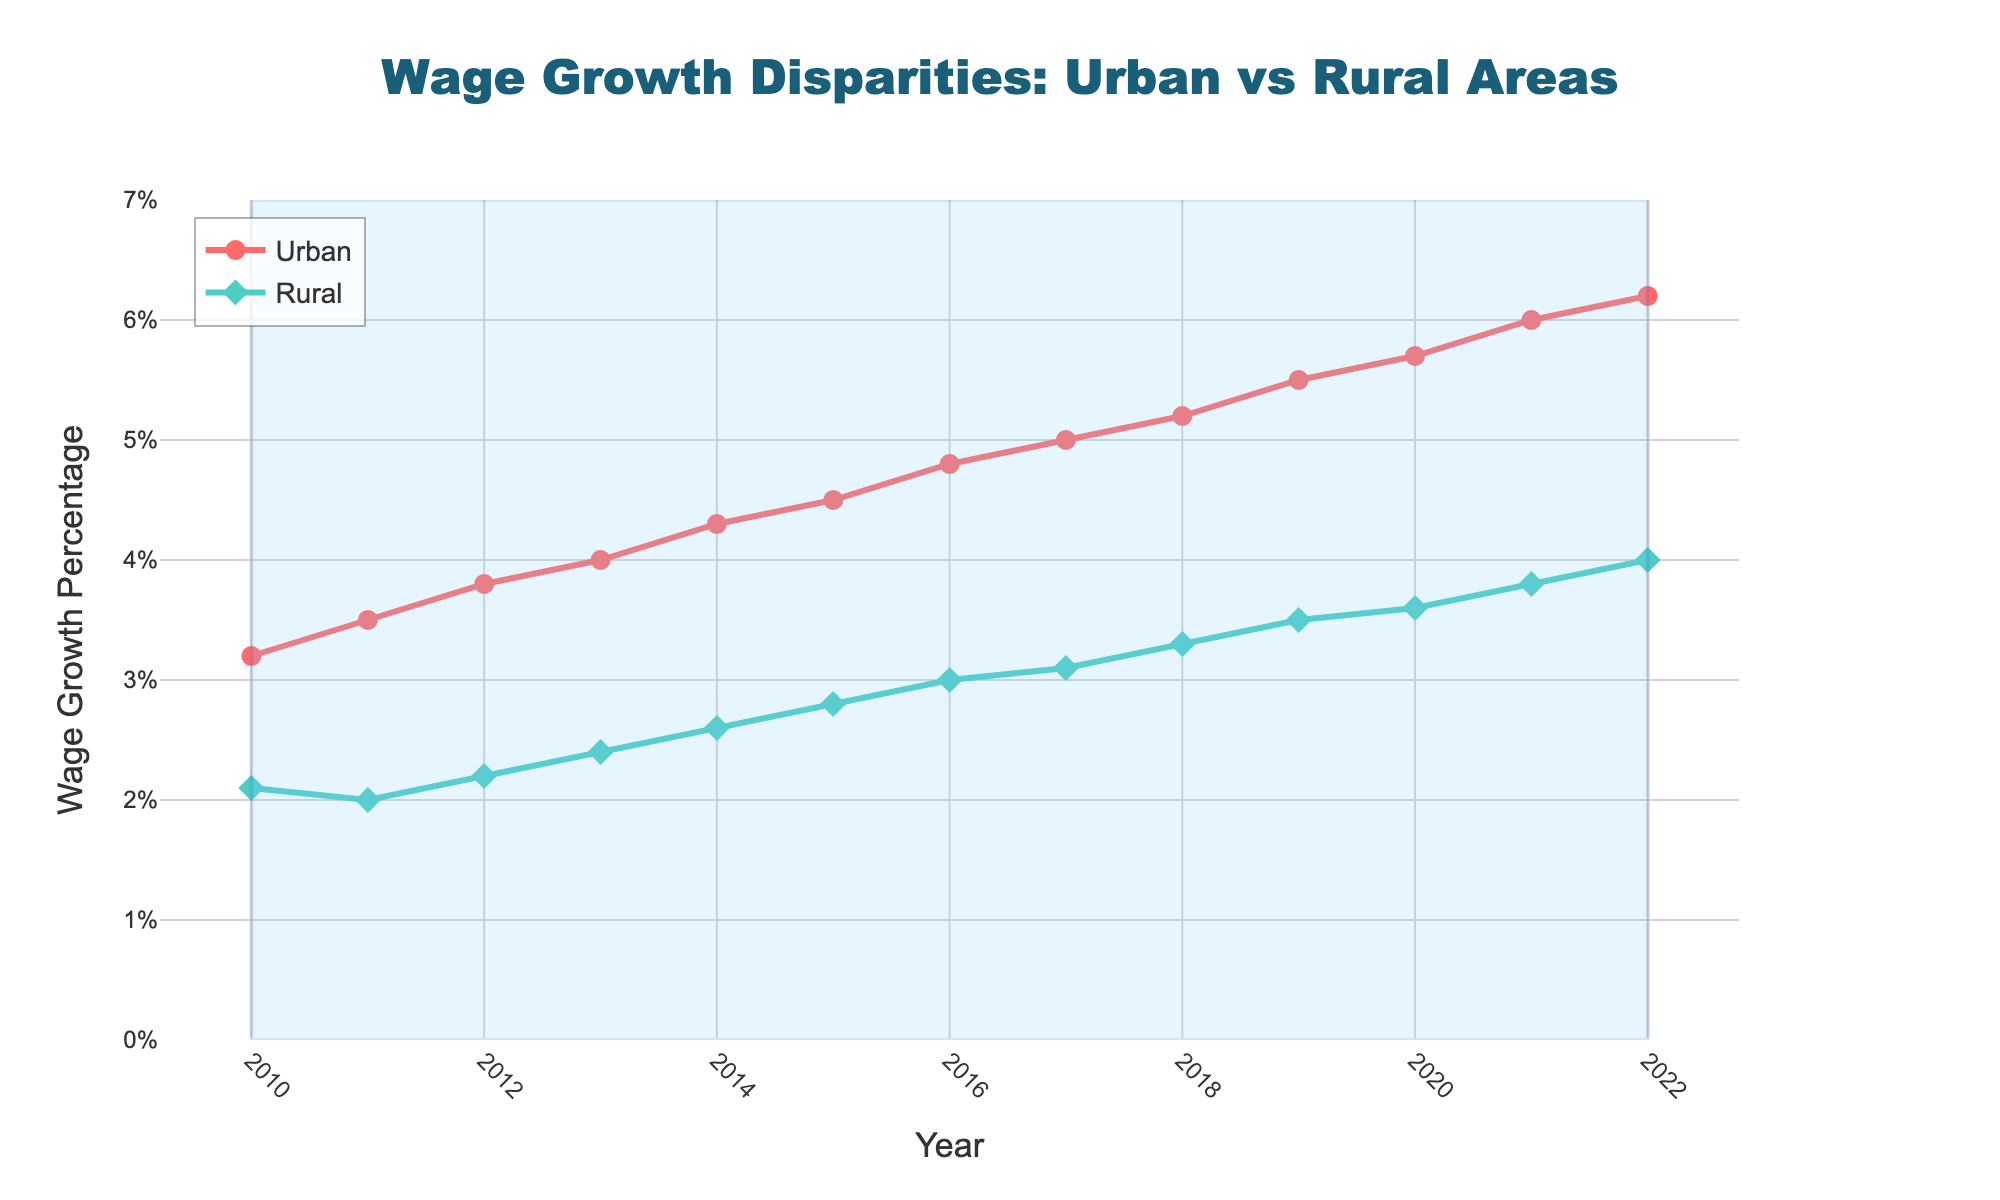What is the chart title? The chart title is located at the top of the figure in a large font. It reads "Wage Growth Disparities: Urban vs. Rural Areas"
Answer: Wage Growth Disparities: Urban vs. Rural Areas Which color represents urban areas? The color representing urban areas can be identified by looking at the legend or the colored line in the plot. It is a red line with circular markers.
Answer: Red Between which years is the data presented? The x-axis of the plot labels the years, and the data ranges from the year 2010 to 2022.
Answer: 2010 to 2022 In which year did urban areas experience the highest wage growth percentage? By examining the highest point on the urban line in the plot, we can see that the peak is in the year 2022.
Answer: 2022 What was the wage growth percentage for rural areas in 2015? By locating the year 2015 on the x-axis and following vertically to the rural line (green line with diamond markers), the wage growth percentage for rural areas in 2015 can be seen as 2.8%.
Answer: 2.8% How does the wage growth percentage in rural areas in 2020 compare to that in 2010? The rural line in 2020 is higher than in 2010. In 2020, it was 3.6%, and in 2010, it was only 2.1%.
Answer: Increased by 1.5% What is the average wage growth percentage for urban areas over the period? Add the wage growth percentages for urban areas from 2010 to 2022 and then divide by the number of years. (3.2 + 3.5 + 3.8 + 4.0 + 4.3 + 4.5 + 4.8 + 5.0 + 5.2 + 5.5 + 5.7 + 6.0 + 6.2) / 13 = 4.72%
Answer: 4.72% By how much did the wage growth percentage in urban areas increase from 2010 to 2022? Subtract the wage growth percentage in 2010 from that in 2022 for urban areas (6.2% - 3.2%) = 3%
Answer: 3% Which year had the smallest disparity in wage growth percentage between urban and rural areas? Calculate the differences for each year and find the smallest: 
2010 (1.1), 2011 (1.5), 2012 (1.6), 2013 (1.6), 2014 (1.7), 2015 (1.7), 2016 (1.8), 2017 (1.9), 2018 (1.9), 2019 (2), 2020 (2.1), 2021 (2.2), 2022 (2.2). Smallest is 2010 with 1.1% disparity.
Answer: 2010 How did the wage growth percentages for urban areas and rural areas change from 2015 to 2016? Observe the line segments for these years. For urban areas, percentages went from 4.5% to 4.8% (increase of 0.3%). For rural areas, percentages went from 2.8% to 3.0% (increase of 0.2%).
Answer: Increase: Urban 0.3%, Rural 0.2% 